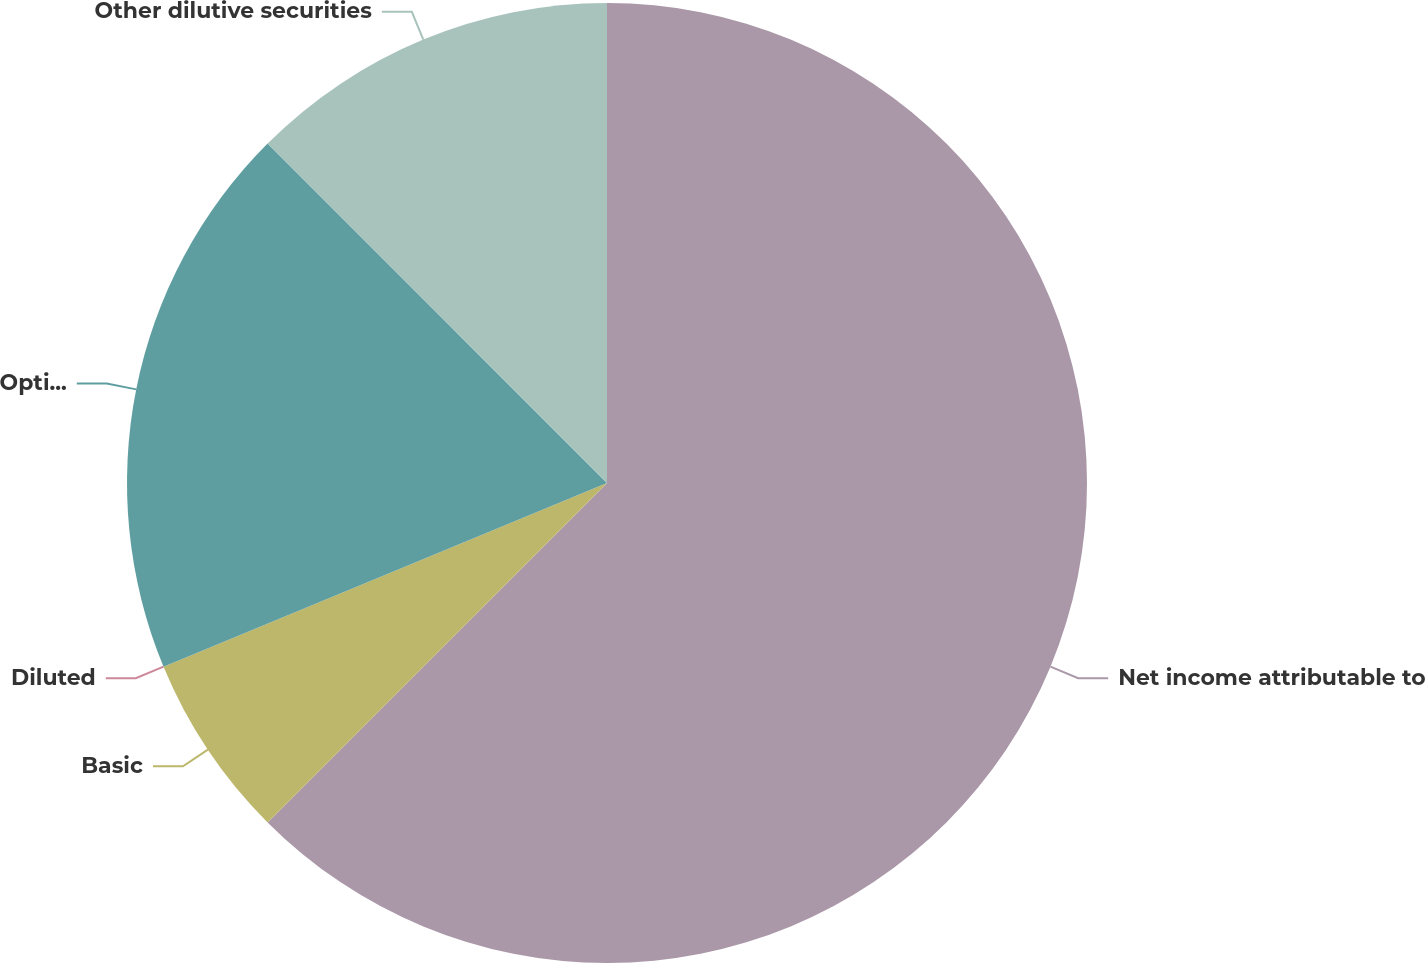<chart> <loc_0><loc_0><loc_500><loc_500><pie_chart><fcel>Net income attributable to<fcel>Basic<fcel>Diluted<fcel>Options to purchase common<fcel>Other dilutive securities<nl><fcel>62.5%<fcel>6.25%<fcel>0.0%<fcel>18.75%<fcel>12.5%<nl></chart> 